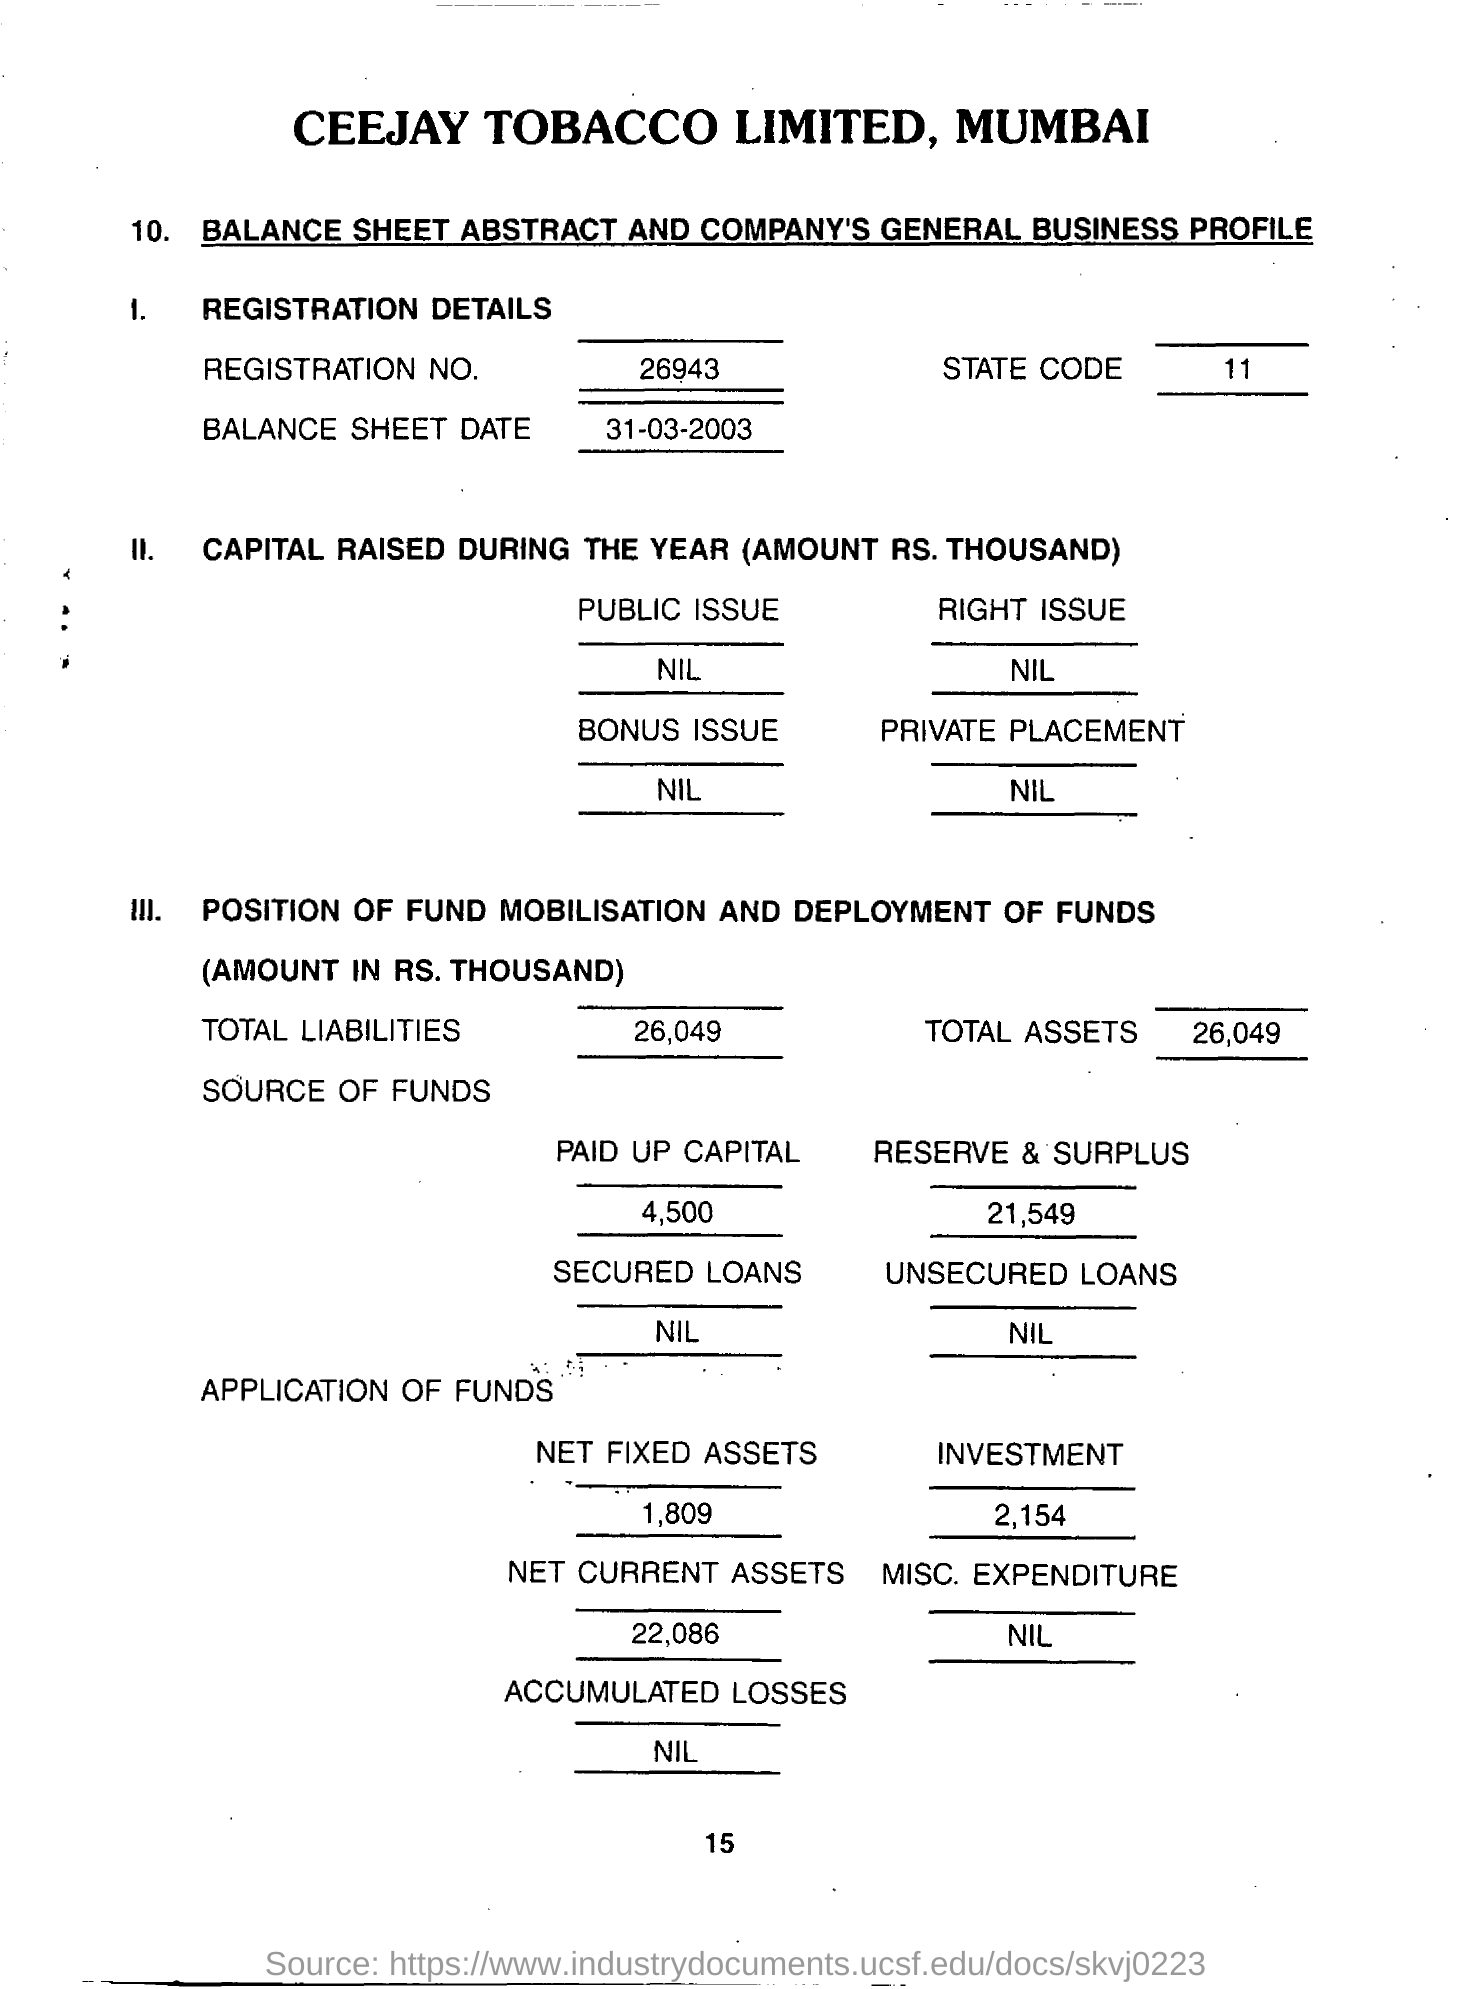What is the Company Name ?
Offer a terse response. CEEJAY TOBACCO LIMITED, MUMBAI. What is the Registration Number ?
Your answer should be very brief. 26943. What is the Balance Sheet Date ?
Make the answer very short. 31-03-2003. What is the State Code?
Your answer should be very brief. 11. How much Total Liabilities ?
Offer a very short reply. 26,049. What is written in the Public Issue Field ?
Keep it short and to the point. NIL. How much Total Assets ?
Offer a terse response. 26,049. How much Paid up Capital ?
Offer a very short reply. 4,500. 